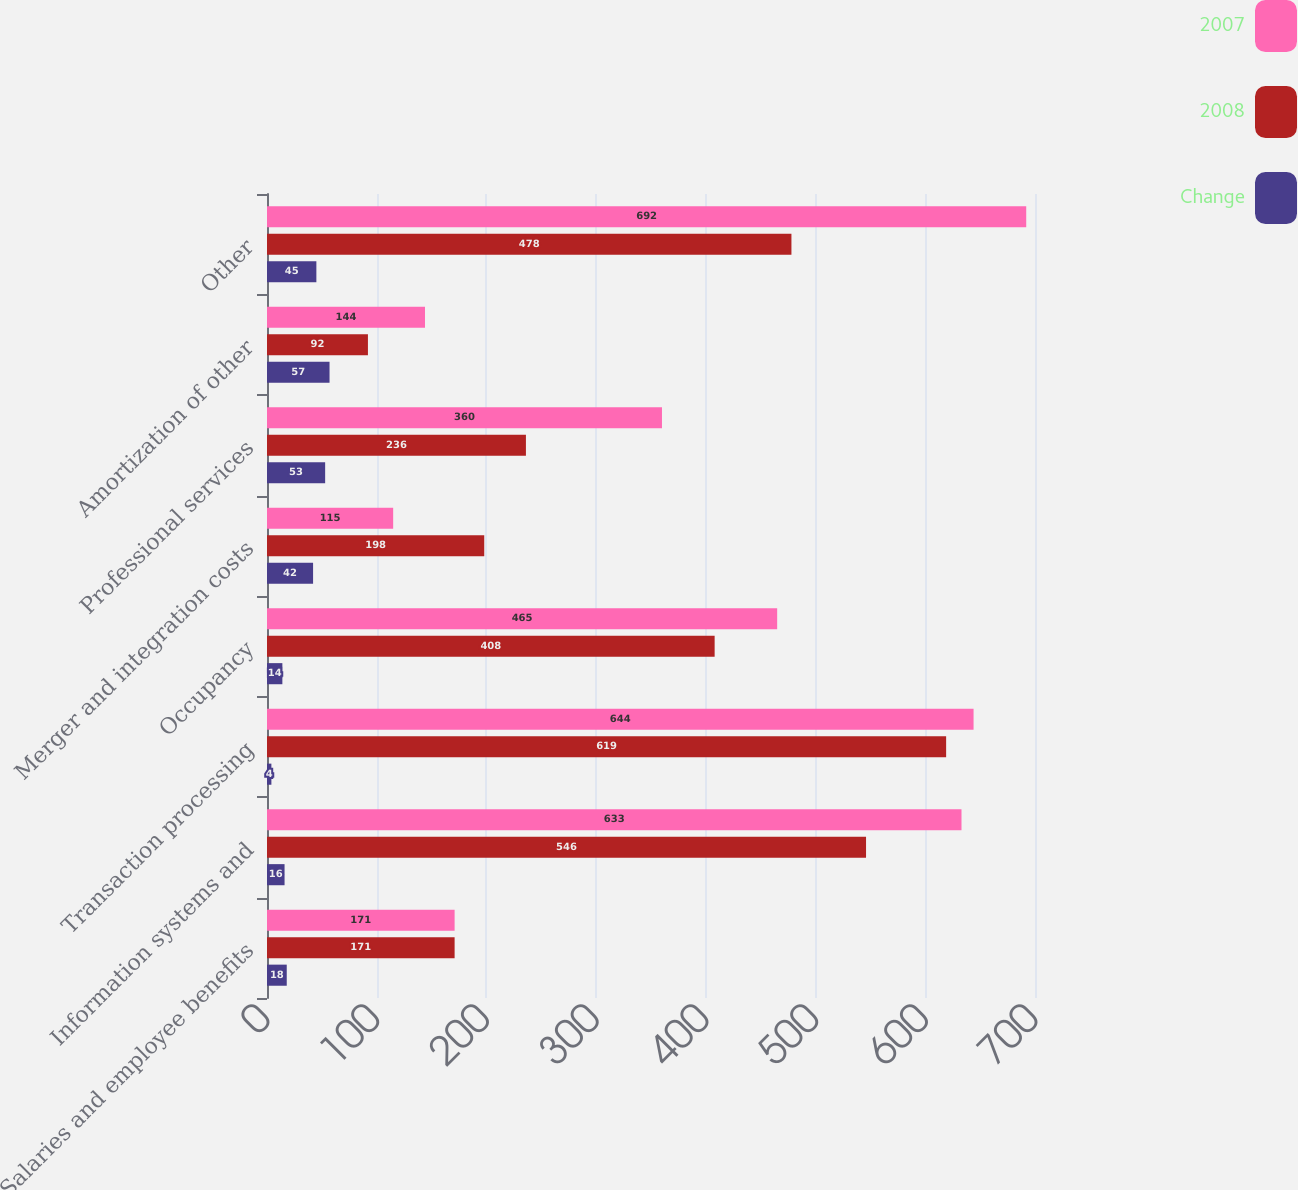Convert chart to OTSL. <chart><loc_0><loc_0><loc_500><loc_500><stacked_bar_chart><ecel><fcel>Salaries and employee benefits<fcel>Information systems and<fcel>Transaction processing<fcel>Occupancy<fcel>Merger and integration costs<fcel>Professional services<fcel>Amortization of other<fcel>Other<nl><fcel>2007<fcel>171<fcel>633<fcel>644<fcel>465<fcel>115<fcel>360<fcel>144<fcel>692<nl><fcel>2008<fcel>171<fcel>546<fcel>619<fcel>408<fcel>198<fcel>236<fcel>92<fcel>478<nl><fcel>Change<fcel>18<fcel>16<fcel>4<fcel>14<fcel>42<fcel>53<fcel>57<fcel>45<nl></chart> 